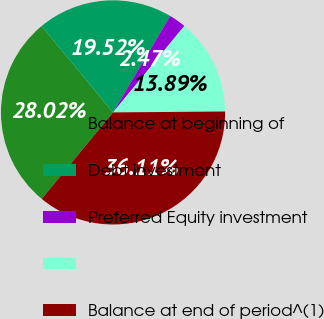Convert chart. <chart><loc_0><loc_0><loc_500><loc_500><pie_chart><fcel>Balance at beginning of<fcel>Debt investment<fcel>Preferred Equity investment<fcel>Unnamed: 3<fcel>Balance at end of period^(1)<nl><fcel>28.02%<fcel>19.52%<fcel>2.47%<fcel>13.89%<fcel>36.11%<nl></chart> 